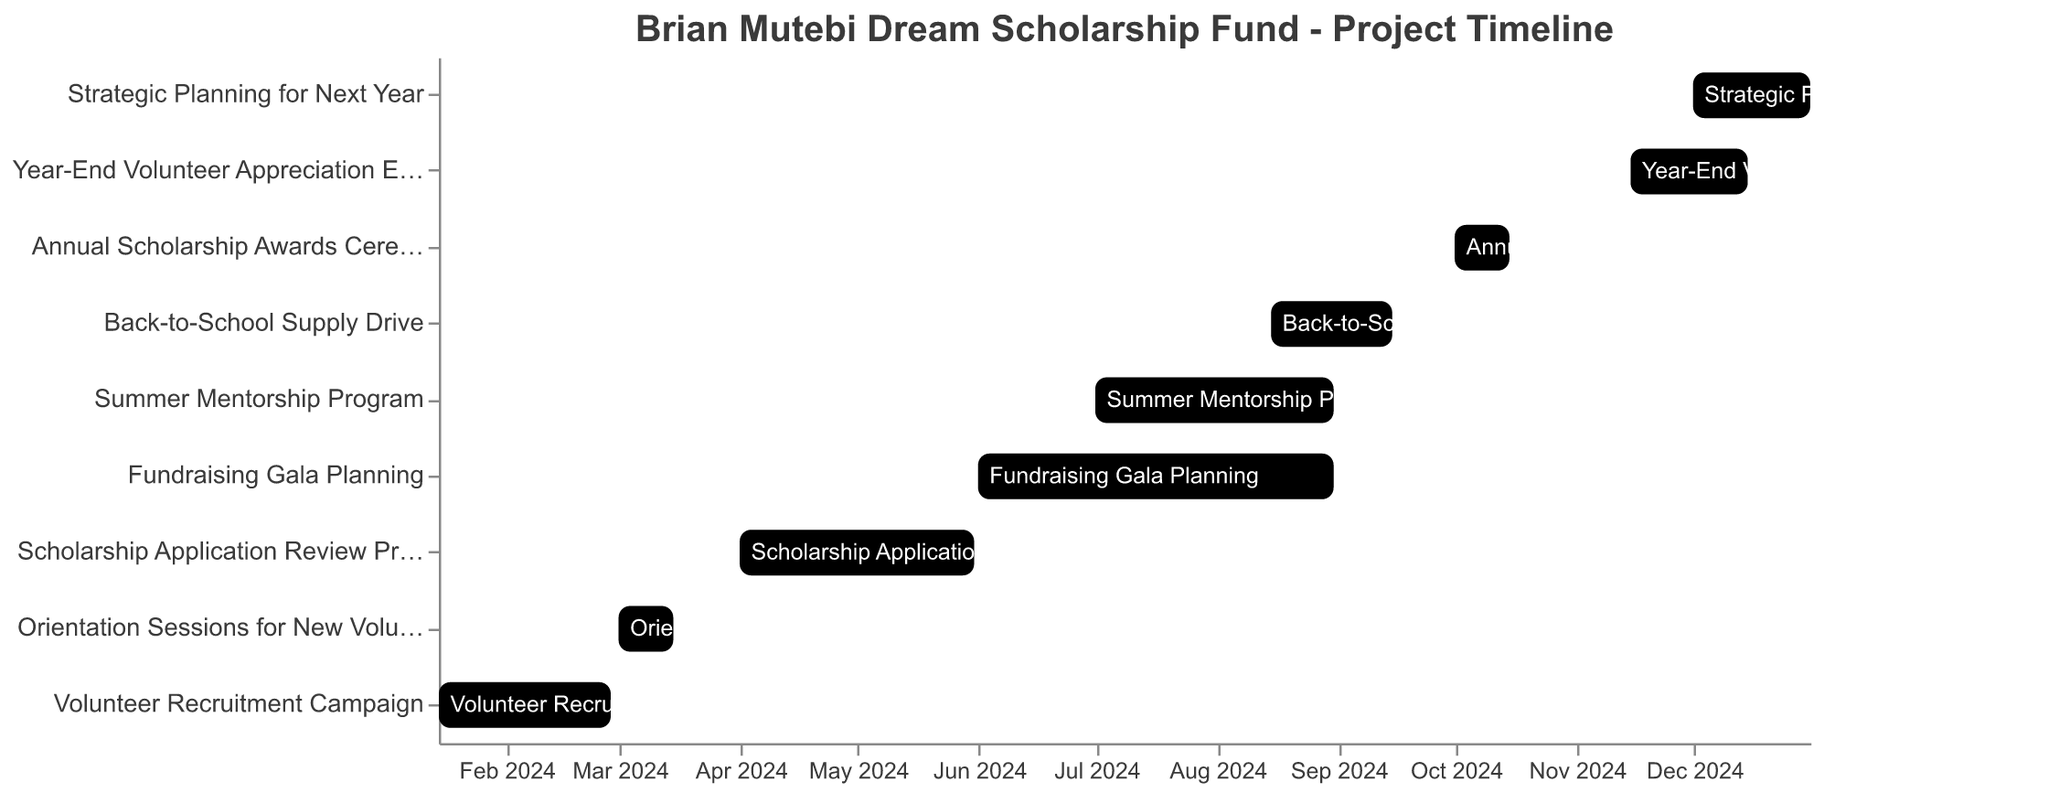Which project task starts the earliest? The earliest start date can be seen at the beginning of the x-axis. The task "Volunteer Recruitment Campaign" starts on 2024-01-15.
Answer: Volunteer Recruitment Campaign How long does the Fundraising Gala Planning task last? The "Fundraising Gala Planning" task has a Duration of 92 days, which can be seen from its entry in the data table.
Answer: 92 days Which task has the shortest duration? By comparing the "Duration" values of each task, the "Orientation Sessions for New Volunteers" has the shortest duration of 15 days.
Answer: Orientation Sessions for New Volunteers Which two tasks overlap in August 2024? Looking at the timeline in August, the "Fundraising Gala Planning" and "Summer Mentorship Program" both occur during this month.
Answer: Fundraising Gala Planning, Summer Mentorship Program Which month has the highest number of concurrent tasks? To find the month with the most concurrent tasks, count the number of overlapping tasks in each month. August 2024 has 3 overlapping tasks: Fundraising Gala Planning, Summer Mentorship Program, and Back-to-School Supply Drive.
Answer: August 2024 How many tasks extend into the fourth quarter of the year (Oct-Dec)? Tasks extending into Q4 are checked for overlaps with dates from October to December. Tasks overlapping into Q4 are: Annual Scholarship Awards Ceremony, Year-End Volunteer Appreciation Event, Strategic Planning for Next Year (3 tasks).
Answer: 3 Which tasks are scheduled for completion in December 2024? The tasks with an End Date in December 2024 are "Year-End Volunteer Appreciation Event" (ends on 2024-12-15) and "Strategic Planning for Next Year" (ends on 2024-12-31).
Answer: Year-End Volunteer Appreciation Event, Strategic Planning for Next Year How many tasks are planned to start in January 2024? "Volunteer Recruitment Campaign" is the only task with a Start Date in January 2024. (1 task).
Answer: 1 Which tasks have an overlapping period with the Back-to-School Supply Drive? Looking at the data, the "Back-to-School Supply Drive" runs from 2024-08-15 to 2024-09-15. The overlapping tasks are "Fundraising Gala Planning" (ends on 2024-08-31) and "Summer Mentorship Program" (ends on 2024-08-31).
Answer: Fundraising Gala Planning, Summer Mentorship Program 